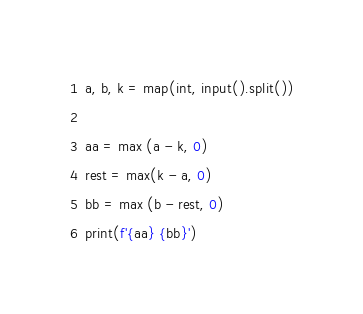<code> <loc_0><loc_0><loc_500><loc_500><_Python_>a, b, k = map(int, input().split())

aa = max (a - k, 0)
rest = max(k - a, 0)
bb = max (b - rest, 0)
print(f'{aa} {bb}')</code> 